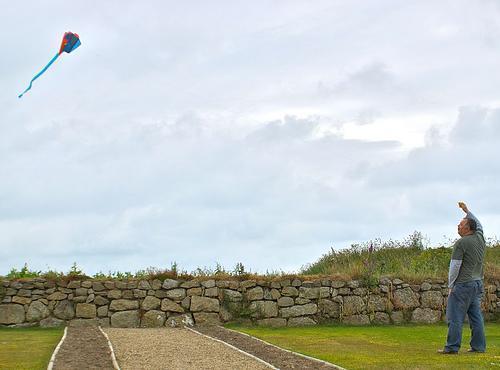How many people are in the photo?
Give a very brief answer. 1. 